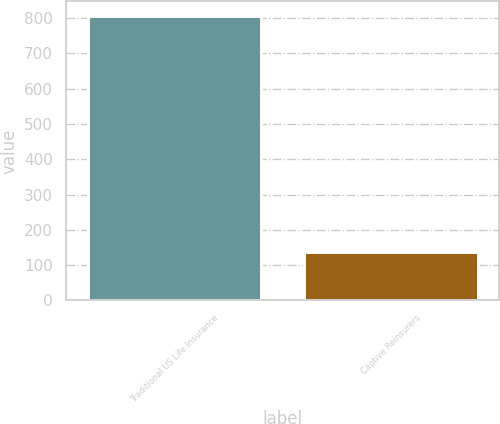<chart> <loc_0><loc_0><loc_500><loc_500><bar_chart><fcel>Traditional US Life Insurance<fcel>Captive Reinsurers<nl><fcel>807.4<fcel>137.1<nl></chart> 